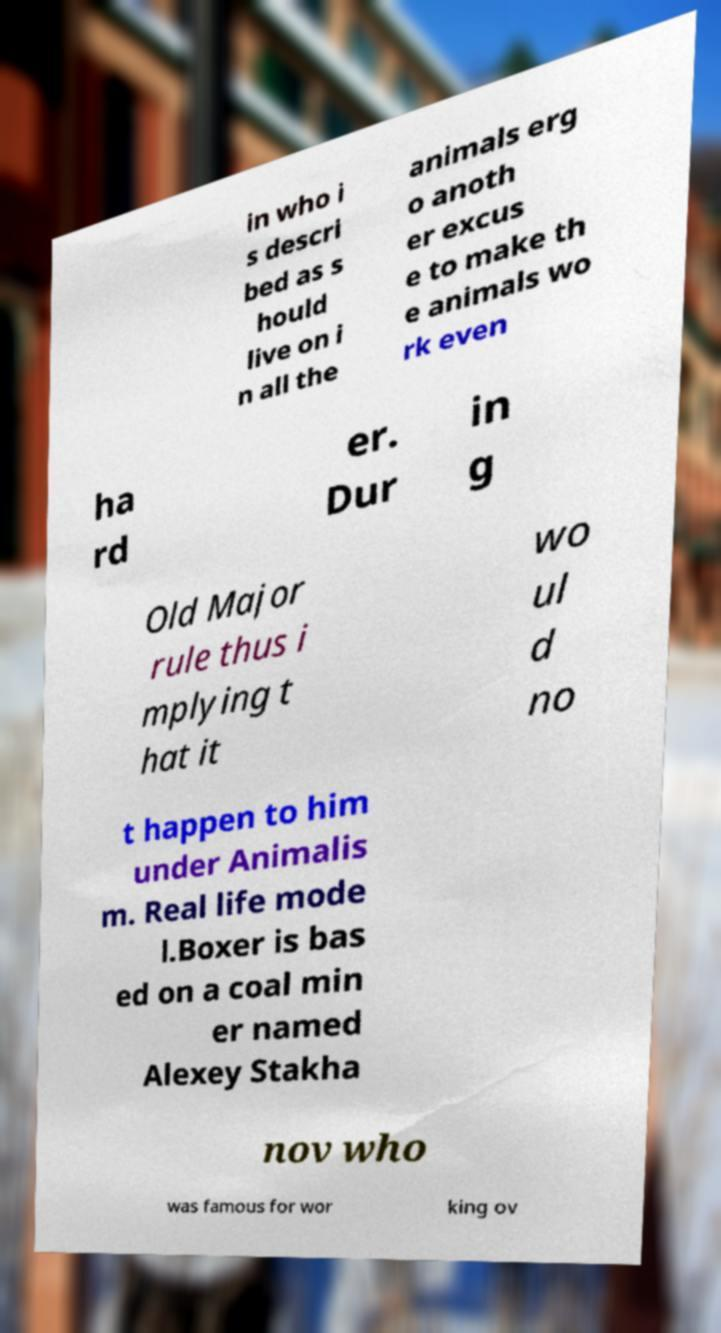There's text embedded in this image that I need extracted. Can you transcribe it verbatim? in who i s descri bed as s hould live on i n all the animals erg o anoth er excus e to make th e animals wo rk even ha rd er. Dur in g Old Major rule thus i mplying t hat it wo ul d no t happen to him under Animalis m. Real life mode l.Boxer is bas ed on a coal min er named Alexey Stakha nov who was famous for wor king ov 